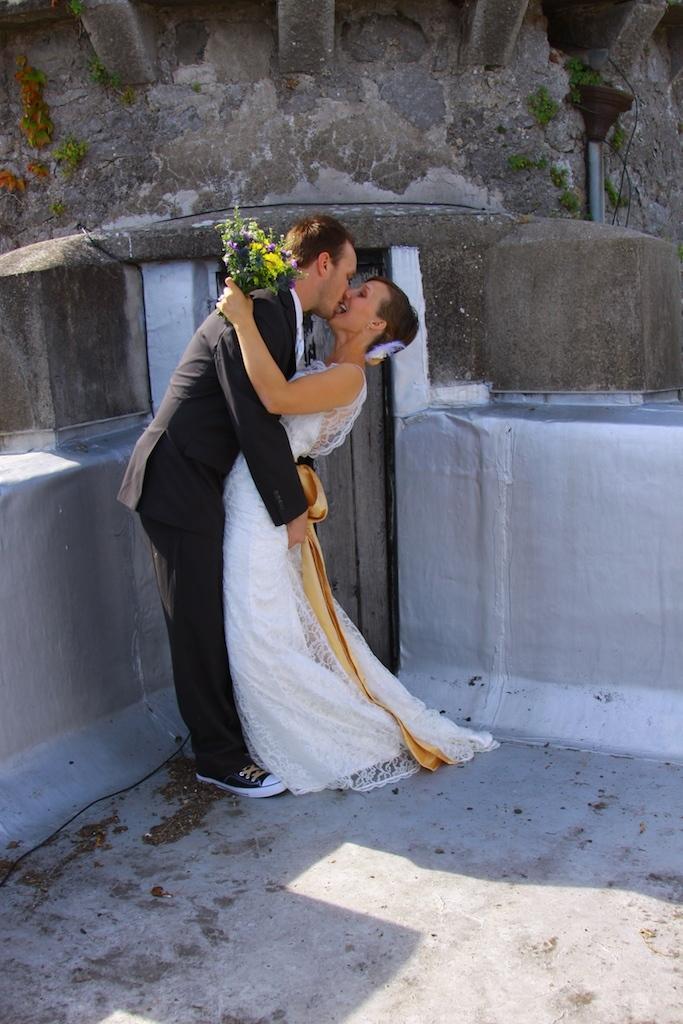How many people are in the image? There are two people in the image. What are the two people doing in the image? The two people are hugging each other. Can you describe what the woman is holding in the image? The woman is holding a flower bouquet. What is the man doing with the woman in the image? The man is holding the woman in his arms. What type of mark can be seen on the woman's dress in the image? There is no mark visible on the woman's dress in the image. What kind of brush is being used by the man in the image? There is no brush present in the image; the man is holding the woman in his arms. 